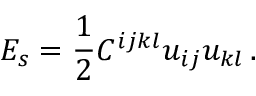<formula> <loc_0><loc_0><loc_500><loc_500>E _ { s } = \frac { 1 } { 2 } C ^ { i j k l } u _ { i j } u _ { k l } \, .</formula> 